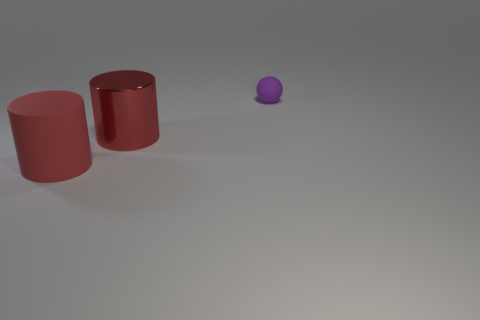Add 3 big rubber things. How many objects exist? 6 Subtract all cylinders. How many objects are left? 1 Subtract all purple matte spheres. Subtract all large gray metal balls. How many objects are left? 2 Add 2 tiny things. How many tiny things are left? 3 Add 2 big gray shiny balls. How many big gray shiny balls exist? 2 Subtract 0 cyan blocks. How many objects are left? 3 